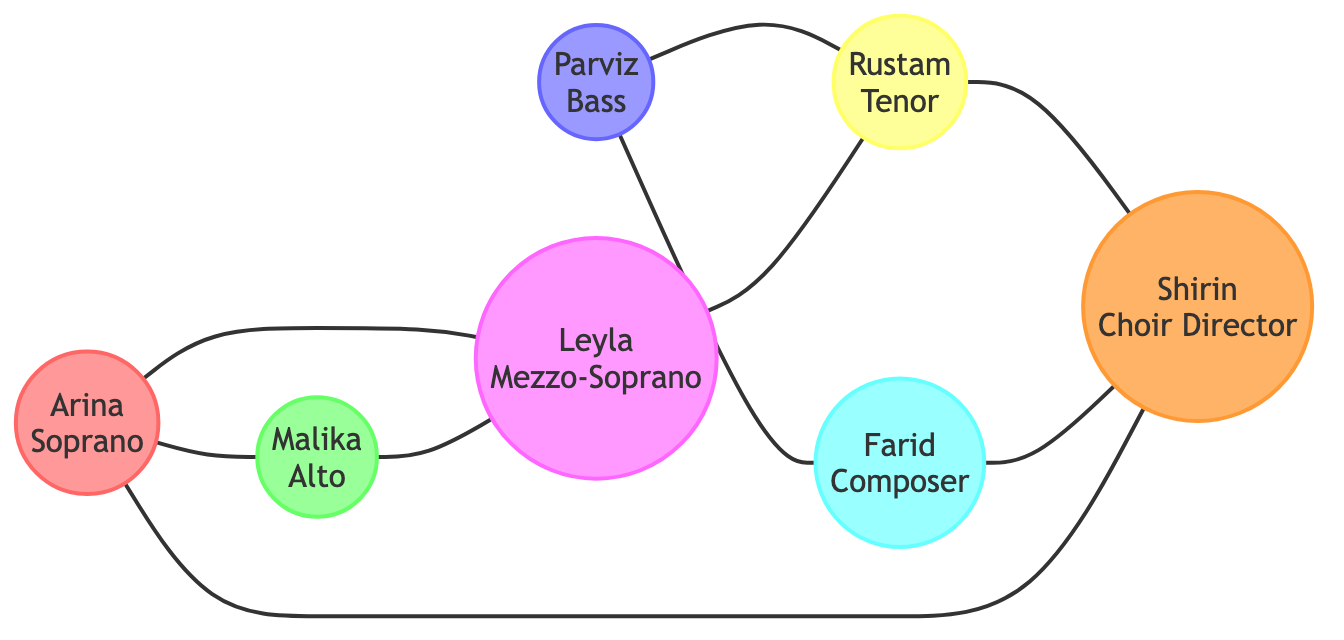What is the total number of friends in the diagram? The diagram lists 7 unique nodes representing friends, which are Arina, Parviz, Malika, Rustam, Leyla, Farid, and Shirin. Counting these friends gives a total of 7.
Answer: 7 Which friend is connected to both Arina and Leyla? The friend who is connected to both Arina and Leyla is Malika, as indicated by the edges connecting these three nodes.
Answer: Malika How many edges connect Arina to other friends? Arina has edges connecting her to Malika, Leyla, and Shirin, accounting for three connections in total.
Answer: 3 Who is the only friend connected to both Rustam and Farid? The friend connected to both Rustam and Farid is Shirin, as shown by the edges leading to her from both nodes.
Answer: Shirin Which friends have a direct connection to the Composer? The friends who have a direct connection to Farid (the Composer) are Parviz and Shirin, as indicated by the edges connecting them.
Answer: Parviz, Shirin Is there a friend who connects both types of singers (Soprano and Bass) in the graph? Leyla, who is a Mezzo-Soprano, connects Soprano (Arina) and Bass (Parviz) through her direct connections, showing her as a bridge between these types.
Answer: Leyla What is the attribute of the friend who is connected directly to Shirin? The friends directly connected to Shirin are Rustam and Arina, but the question asks for their attributes. Shirin is a Choir Director, and both connections are to a Tenor and a Soprano, respectively.
Answer: Tenor, Soprano 